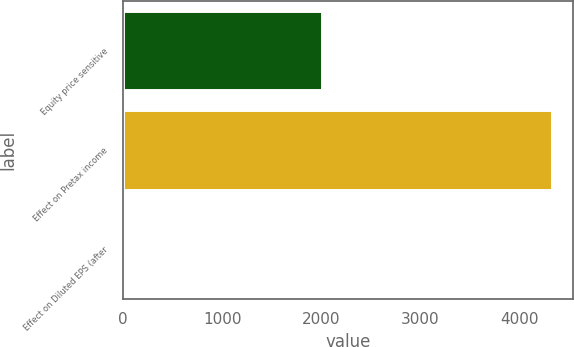Convert chart to OTSL. <chart><loc_0><loc_0><loc_500><loc_500><bar_chart><fcel>Equity price sensitive<fcel>Effect on Pretax income<fcel>Effect on Diluted EPS (after<nl><fcel>2006<fcel>4333<fcel>0.04<nl></chart> 